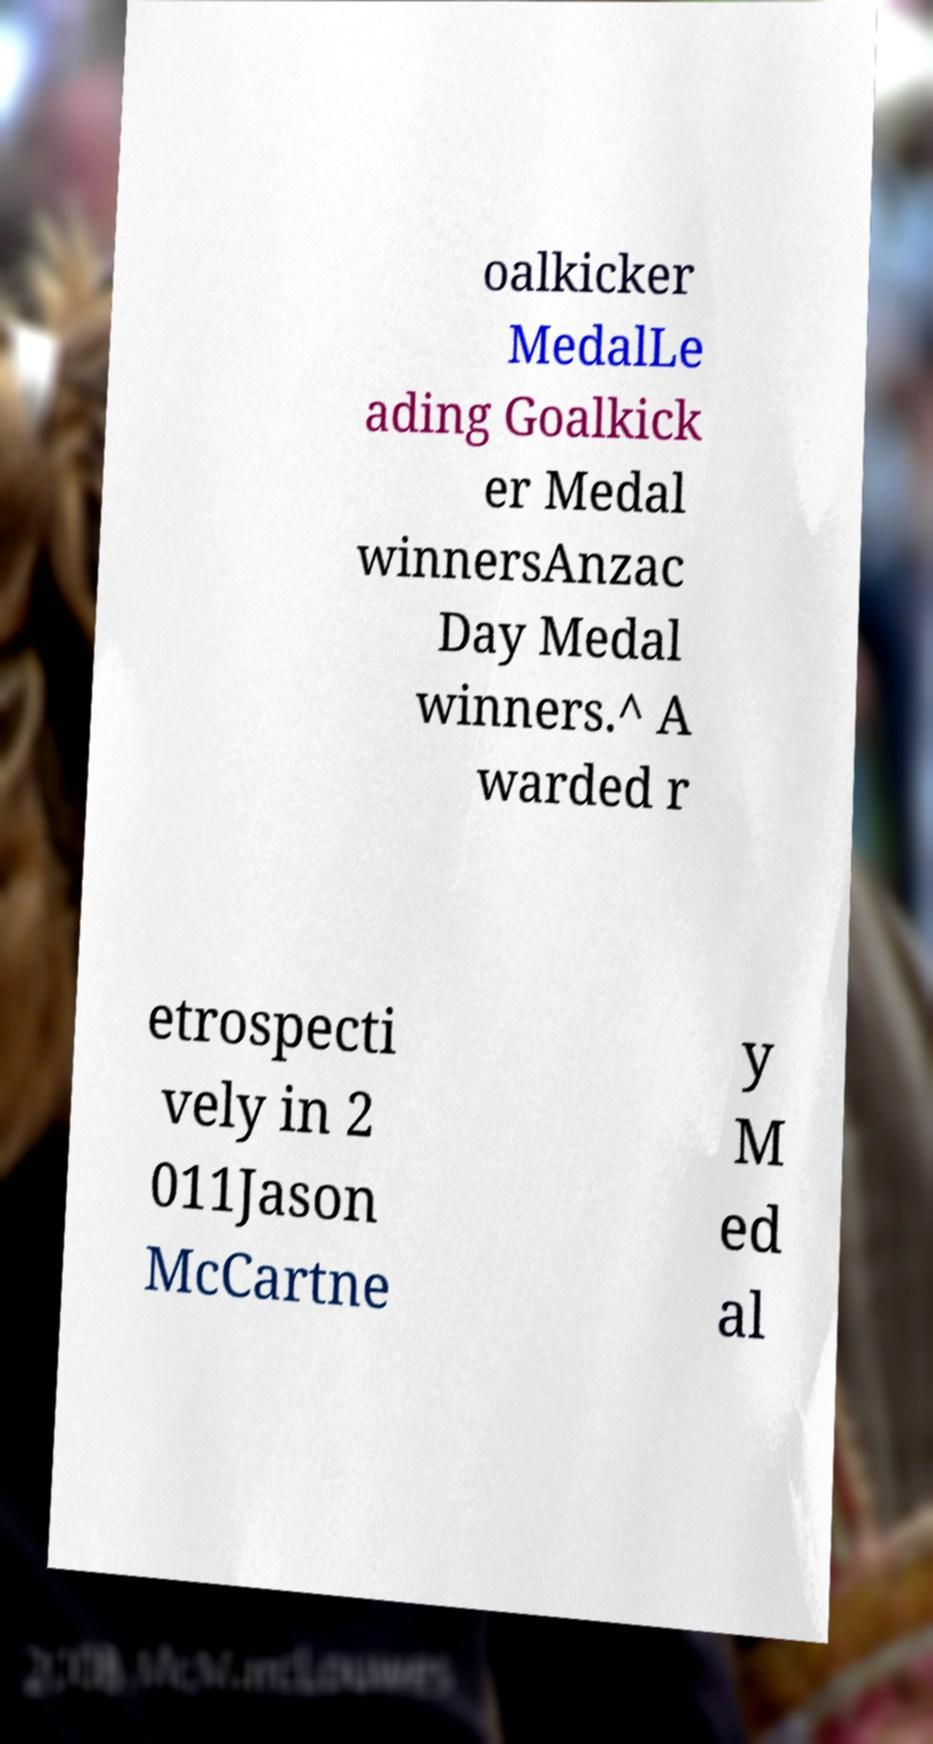For documentation purposes, I need the text within this image transcribed. Could you provide that? oalkicker MedalLe ading Goalkick er Medal winnersAnzac Day Medal winners.^ A warded r etrospecti vely in 2 011Jason McCartne y M ed al 